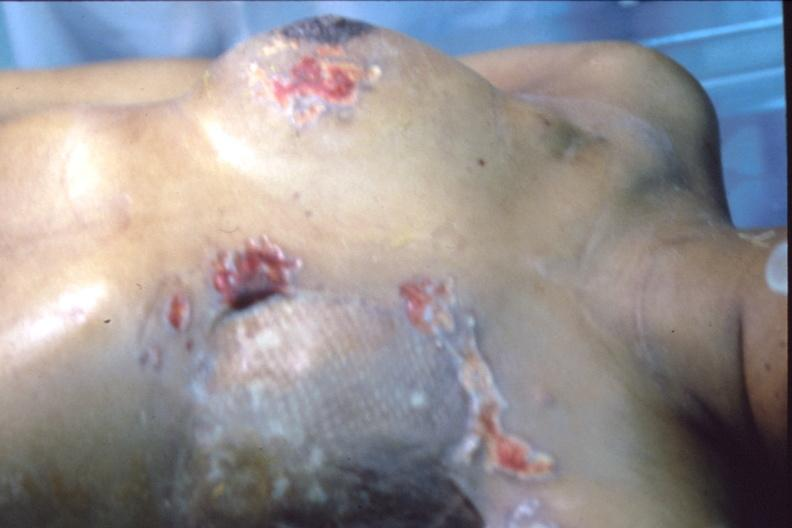s typical tuberculous exudate present?
Answer the question using a single word or phrase. No 